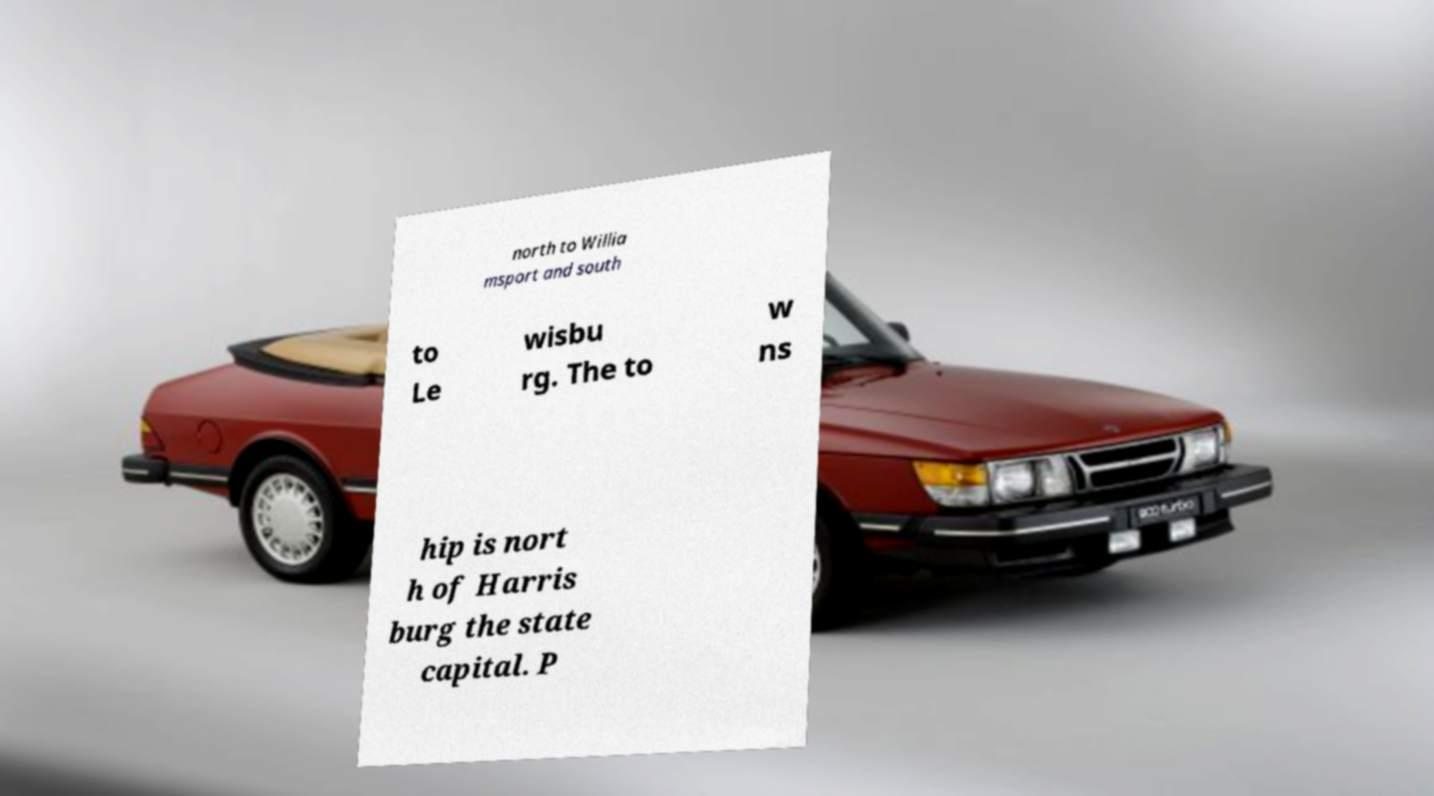Please read and relay the text visible in this image. What does it say? north to Willia msport and south to Le wisbu rg. The to w ns hip is nort h of Harris burg the state capital. P 